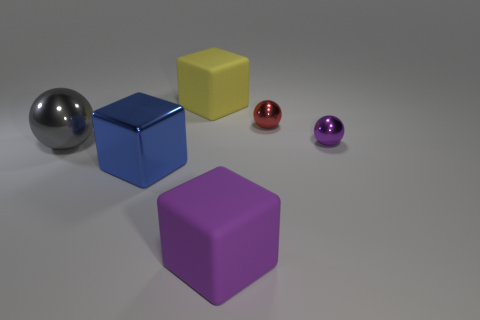What material is the purple thing that is the same shape as the blue metallic object?
Give a very brief answer. Rubber. Are there any red metallic spheres left of the large purple matte cube?
Provide a short and direct response. No. There is a yellow matte cube; is it the same size as the rubber block that is in front of the yellow object?
Ensure brevity in your answer.  Yes. The rubber object behind the tiny purple shiny object that is behind the gray ball is what color?
Give a very brief answer. Yellow. Is the yellow rubber block the same size as the gray metal ball?
Keep it short and to the point. Yes. The big thing that is both behind the big purple rubber cube and in front of the big gray metal object is what color?
Provide a succinct answer. Blue. How big is the blue metal cube?
Make the answer very short. Large. Do the tiny metal object right of the small red metallic sphere and the large metallic sphere have the same color?
Provide a short and direct response. No. Are there more purple shiny balls behind the small red metallic sphere than large rubber objects that are to the right of the large purple matte object?
Keep it short and to the point. No. Is the number of big balls greater than the number of tiny brown rubber things?
Your response must be concise. Yes. 